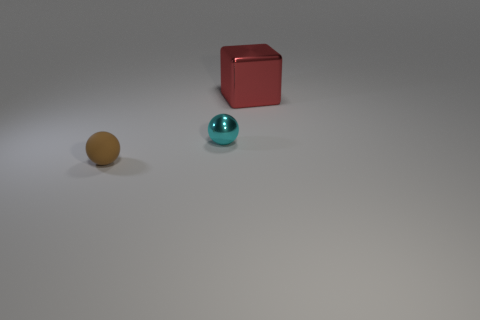There is a shiny thing left of the large red metallic block; how big is it?
Your answer should be very brief. Small. The object that is both behind the small brown sphere and on the left side of the red cube has what shape?
Provide a succinct answer. Sphere. What number of big red things have the same material as the large block?
Your answer should be compact. 0. Are there more large brown metallic cylinders than small brown objects?
Your answer should be very brief. No. What is the color of the metal sphere?
Offer a very short reply. Cyan. How many matte things are the same color as the large metallic thing?
Your answer should be very brief. 0. There is a tiny object that is right of the tiny brown ball; does it have the same shape as the large red metal object?
Offer a terse response. No. Are there fewer brown spheres that are in front of the big red object than cyan objects that are on the left side of the cyan sphere?
Ensure brevity in your answer.  No. What is the material of the object that is left of the shiny sphere?
Ensure brevity in your answer.  Rubber. Is there a object that has the same size as the rubber ball?
Give a very brief answer. Yes. 